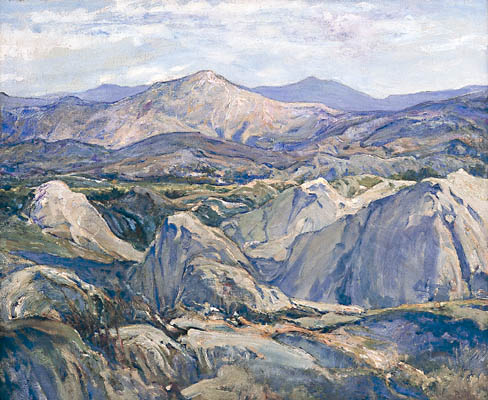If this landscape were to be the setting of a fantasy novel, what kind of story would unfold here? In this vast, untouched wilderness, a hidden realm of ancient magic thrives, unnoticed by the inhabitants of the nearby villages. The mountains, shrouded in mist and mystery, are said to be the birthplace of dragons, creatures of wisdom and power who roam the skies at twilight. The rolling hills and serene valleys are home to various mystical beings, from the elusive forest spirits to the wise centaurs who guard the secrets of the hills.

Our story follows a young adventurer named Elara, who embarks on a quest to uncover the truth about her heritage. Guided by cryptic dreams and the whispers of the wind, she must traverse this enchanting landscape to find the Dragon’s Heart, an ancient artifact said to grant unparalleled power to its holder.

Along her journey, Elara encounters formidable challenges and allies. She befriends a misfit band of magical creatures, including Sylvan, a mischievous forest sprite, and Theros, a noble centaur warrior. Together, they must navigate treacherous paths, decipher ancient riddles, and confront the dark forces that threaten to plunge their world into chaos. The landscape, with its serene beauty and hidden perils, becomes a character in its own right, shaping and testing Elara in ways she never imagined. 